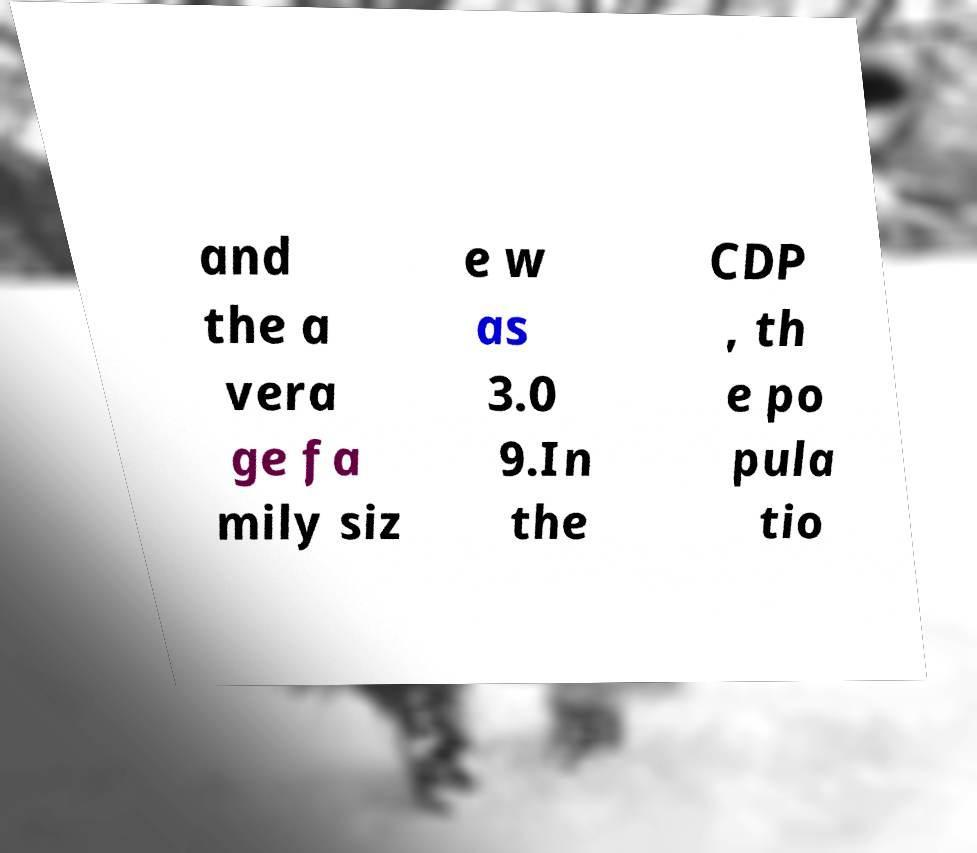Can you read and provide the text displayed in the image?This photo seems to have some interesting text. Can you extract and type it out for me? and the a vera ge fa mily siz e w as 3.0 9.In the CDP , th e po pula tio 